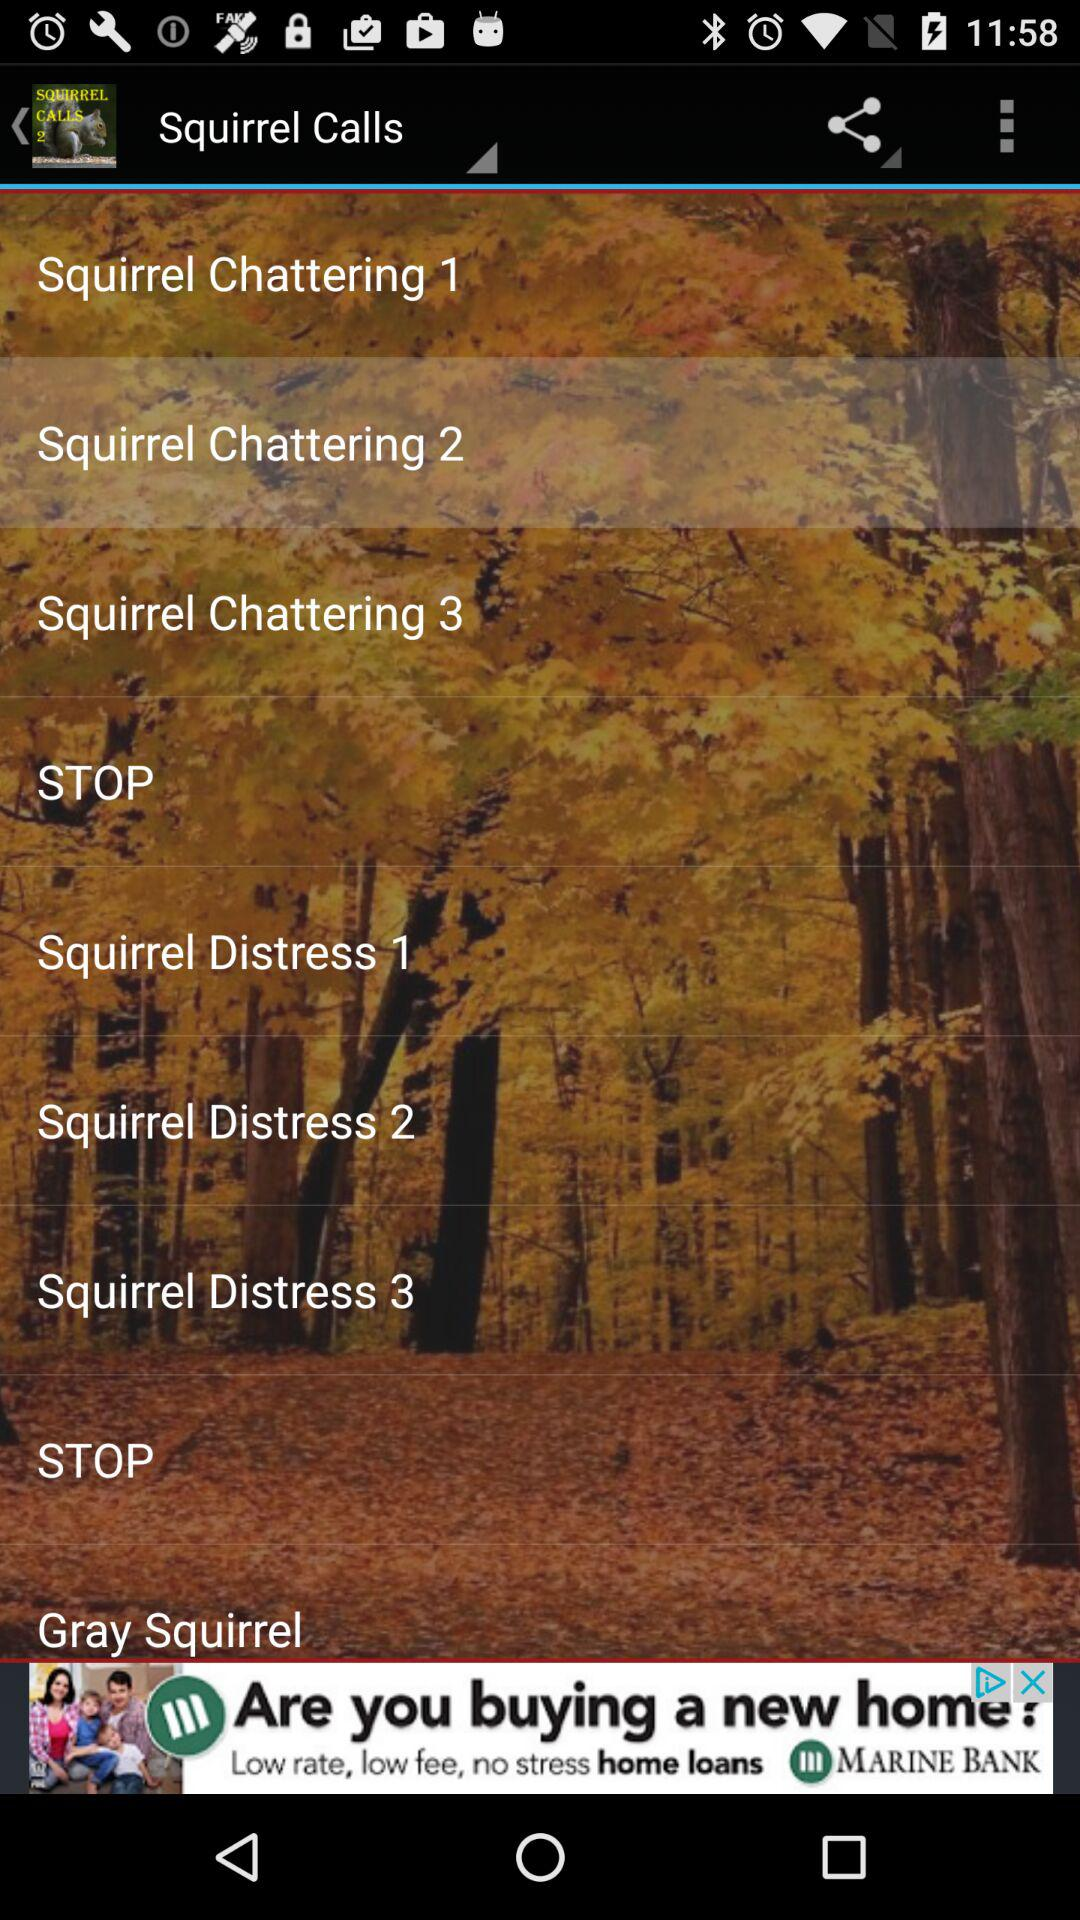How many squirrel distress items are there?
Answer the question using a single word or phrase. 3 